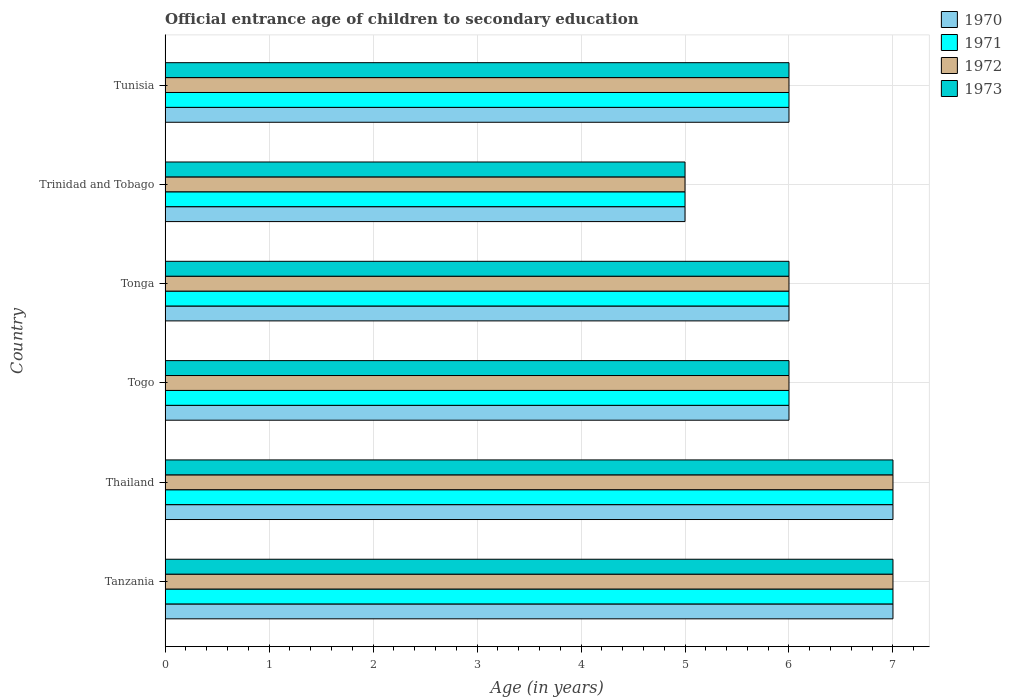How many different coloured bars are there?
Give a very brief answer. 4. How many groups of bars are there?
Your response must be concise. 6. Are the number of bars on each tick of the Y-axis equal?
Offer a very short reply. Yes. What is the label of the 4th group of bars from the top?
Provide a short and direct response. Togo. In how many cases, is the number of bars for a given country not equal to the number of legend labels?
Your response must be concise. 0. Across all countries, what is the minimum secondary school starting age of children in 1973?
Your answer should be very brief. 5. In which country was the secondary school starting age of children in 1972 maximum?
Provide a succinct answer. Tanzania. In which country was the secondary school starting age of children in 1970 minimum?
Provide a succinct answer. Trinidad and Tobago. What is the total secondary school starting age of children in 1972 in the graph?
Provide a succinct answer. 37. What is the difference between the secondary school starting age of children in 1973 in Togo and the secondary school starting age of children in 1970 in Thailand?
Provide a short and direct response. -1. What is the average secondary school starting age of children in 1973 per country?
Your response must be concise. 6.17. What is the difference between the secondary school starting age of children in 1973 and secondary school starting age of children in 1970 in Togo?
Your answer should be compact. 0. What is the ratio of the secondary school starting age of children in 1971 in Trinidad and Tobago to that in Tunisia?
Provide a short and direct response. 0.83. Is the difference between the secondary school starting age of children in 1973 in Trinidad and Tobago and Tunisia greater than the difference between the secondary school starting age of children in 1970 in Trinidad and Tobago and Tunisia?
Provide a short and direct response. No. What is the difference between the highest and the lowest secondary school starting age of children in 1970?
Keep it short and to the point. 2. In how many countries, is the secondary school starting age of children in 1973 greater than the average secondary school starting age of children in 1973 taken over all countries?
Make the answer very short. 2. Is the sum of the secondary school starting age of children in 1970 in Trinidad and Tobago and Tunisia greater than the maximum secondary school starting age of children in 1973 across all countries?
Offer a very short reply. Yes. What does the 1st bar from the top in Trinidad and Tobago represents?
Your answer should be very brief. 1973. Is it the case that in every country, the sum of the secondary school starting age of children in 1970 and secondary school starting age of children in 1972 is greater than the secondary school starting age of children in 1973?
Make the answer very short. Yes. How many bars are there?
Make the answer very short. 24. What is the difference between two consecutive major ticks on the X-axis?
Offer a very short reply. 1. Are the values on the major ticks of X-axis written in scientific E-notation?
Offer a terse response. No. Does the graph contain any zero values?
Give a very brief answer. No. How are the legend labels stacked?
Your response must be concise. Vertical. What is the title of the graph?
Offer a very short reply. Official entrance age of children to secondary education. Does "1977" appear as one of the legend labels in the graph?
Offer a terse response. No. What is the label or title of the X-axis?
Your response must be concise. Age (in years). What is the label or title of the Y-axis?
Ensure brevity in your answer.  Country. What is the Age (in years) of 1970 in Tanzania?
Your response must be concise. 7. What is the Age (in years) in 1972 in Thailand?
Offer a terse response. 7. What is the Age (in years) in 1971 in Togo?
Offer a terse response. 6. What is the Age (in years) of 1972 in Togo?
Ensure brevity in your answer.  6. What is the Age (in years) of 1973 in Togo?
Provide a short and direct response. 6. What is the Age (in years) in 1970 in Tonga?
Your answer should be compact. 6. What is the Age (in years) of 1972 in Tonga?
Provide a succinct answer. 6. What is the Age (in years) in 1973 in Tonga?
Make the answer very short. 6. What is the Age (in years) in 1971 in Trinidad and Tobago?
Your response must be concise. 5. What is the Age (in years) of 1972 in Trinidad and Tobago?
Provide a short and direct response. 5. What is the Age (in years) in 1973 in Trinidad and Tobago?
Keep it short and to the point. 5. What is the Age (in years) in 1973 in Tunisia?
Your answer should be very brief. 6. Across all countries, what is the maximum Age (in years) in 1970?
Your answer should be compact. 7. Across all countries, what is the maximum Age (in years) in 1971?
Your answer should be very brief. 7. Across all countries, what is the maximum Age (in years) of 1973?
Offer a very short reply. 7. Across all countries, what is the minimum Age (in years) of 1970?
Provide a succinct answer. 5. Across all countries, what is the minimum Age (in years) of 1971?
Make the answer very short. 5. What is the total Age (in years) in 1970 in the graph?
Keep it short and to the point. 37. What is the total Age (in years) in 1973 in the graph?
Ensure brevity in your answer.  37. What is the difference between the Age (in years) of 1971 in Tanzania and that in Thailand?
Provide a short and direct response. 0. What is the difference between the Age (in years) in 1972 in Tanzania and that in Thailand?
Provide a succinct answer. 0. What is the difference between the Age (in years) of 1973 in Tanzania and that in Thailand?
Provide a succinct answer. 0. What is the difference between the Age (in years) in 1970 in Tanzania and that in Togo?
Keep it short and to the point. 1. What is the difference between the Age (in years) of 1971 in Tanzania and that in Togo?
Give a very brief answer. 1. What is the difference between the Age (in years) of 1973 in Tanzania and that in Togo?
Give a very brief answer. 1. What is the difference between the Age (in years) in 1970 in Tanzania and that in Tonga?
Give a very brief answer. 1. What is the difference between the Age (in years) in 1970 in Tanzania and that in Trinidad and Tobago?
Make the answer very short. 2. What is the difference between the Age (in years) of 1972 in Tanzania and that in Trinidad and Tobago?
Give a very brief answer. 2. What is the difference between the Age (in years) of 1970 in Tanzania and that in Tunisia?
Provide a succinct answer. 1. What is the difference between the Age (in years) in 1971 in Tanzania and that in Tunisia?
Your answer should be compact. 1. What is the difference between the Age (in years) in 1973 in Tanzania and that in Tunisia?
Make the answer very short. 1. What is the difference between the Age (in years) of 1970 in Thailand and that in Togo?
Offer a terse response. 1. What is the difference between the Age (in years) in 1972 in Thailand and that in Togo?
Your response must be concise. 1. What is the difference between the Age (in years) of 1973 in Thailand and that in Togo?
Offer a very short reply. 1. What is the difference between the Age (in years) in 1972 in Thailand and that in Tonga?
Offer a terse response. 1. What is the difference between the Age (in years) in 1973 in Thailand and that in Tonga?
Make the answer very short. 1. What is the difference between the Age (in years) in 1971 in Thailand and that in Trinidad and Tobago?
Your answer should be compact. 2. What is the difference between the Age (in years) in 1972 in Thailand and that in Trinidad and Tobago?
Your response must be concise. 2. What is the difference between the Age (in years) of 1970 in Thailand and that in Tunisia?
Your answer should be compact. 1. What is the difference between the Age (in years) of 1971 in Thailand and that in Tunisia?
Keep it short and to the point. 1. What is the difference between the Age (in years) in 1973 in Thailand and that in Tunisia?
Ensure brevity in your answer.  1. What is the difference between the Age (in years) in 1970 in Togo and that in Tonga?
Ensure brevity in your answer.  0. What is the difference between the Age (in years) of 1972 in Togo and that in Tonga?
Provide a succinct answer. 0. What is the difference between the Age (in years) in 1973 in Togo and that in Tonga?
Your response must be concise. 0. What is the difference between the Age (in years) of 1970 in Togo and that in Trinidad and Tobago?
Your response must be concise. 1. What is the difference between the Age (in years) in 1973 in Togo and that in Trinidad and Tobago?
Your answer should be very brief. 1. What is the difference between the Age (in years) in 1972 in Togo and that in Tunisia?
Make the answer very short. 0. What is the difference between the Age (in years) in 1973 in Togo and that in Tunisia?
Provide a succinct answer. 0. What is the difference between the Age (in years) of 1970 in Tonga and that in Trinidad and Tobago?
Keep it short and to the point. 1. What is the difference between the Age (in years) in 1971 in Tonga and that in Trinidad and Tobago?
Your answer should be compact. 1. What is the difference between the Age (in years) of 1971 in Tonga and that in Tunisia?
Make the answer very short. 0. What is the difference between the Age (in years) in 1970 in Trinidad and Tobago and that in Tunisia?
Make the answer very short. -1. What is the difference between the Age (in years) of 1971 in Trinidad and Tobago and that in Tunisia?
Offer a very short reply. -1. What is the difference between the Age (in years) in 1972 in Trinidad and Tobago and that in Tunisia?
Offer a terse response. -1. What is the difference between the Age (in years) of 1970 in Tanzania and the Age (in years) of 1971 in Thailand?
Give a very brief answer. 0. What is the difference between the Age (in years) of 1970 in Tanzania and the Age (in years) of 1972 in Thailand?
Ensure brevity in your answer.  0. What is the difference between the Age (in years) in 1971 in Tanzania and the Age (in years) in 1973 in Thailand?
Your response must be concise. 0. What is the difference between the Age (in years) in 1970 in Tanzania and the Age (in years) in 1971 in Togo?
Your answer should be very brief. 1. What is the difference between the Age (in years) in 1970 in Tanzania and the Age (in years) in 1972 in Togo?
Your response must be concise. 1. What is the difference between the Age (in years) of 1972 in Tanzania and the Age (in years) of 1973 in Togo?
Keep it short and to the point. 1. What is the difference between the Age (in years) of 1970 in Tanzania and the Age (in years) of 1972 in Tonga?
Your answer should be compact. 1. What is the difference between the Age (in years) in 1971 in Tanzania and the Age (in years) in 1973 in Tonga?
Provide a short and direct response. 1. What is the difference between the Age (in years) in 1971 in Tanzania and the Age (in years) in 1973 in Trinidad and Tobago?
Your answer should be compact. 2. What is the difference between the Age (in years) of 1972 in Tanzania and the Age (in years) of 1973 in Trinidad and Tobago?
Your response must be concise. 2. What is the difference between the Age (in years) in 1971 in Tanzania and the Age (in years) in 1972 in Tunisia?
Keep it short and to the point. 1. What is the difference between the Age (in years) of 1970 in Thailand and the Age (in years) of 1972 in Togo?
Provide a succinct answer. 1. What is the difference between the Age (in years) in 1971 in Thailand and the Age (in years) in 1972 in Togo?
Your answer should be very brief. 1. What is the difference between the Age (in years) in 1970 in Thailand and the Age (in years) in 1971 in Tonga?
Provide a short and direct response. 1. What is the difference between the Age (in years) of 1970 in Thailand and the Age (in years) of 1972 in Tonga?
Offer a terse response. 1. What is the difference between the Age (in years) in 1970 in Thailand and the Age (in years) in 1973 in Tonga?
Provide a short and direct response. 1. What is the difference between the Age (in years) of 1972 in Thailand and the Age (in years) of 1973 in Tonga?
Make the answer very short. 1. What is the difference between the Age (in years) in 1970 in Thailand and the Age (in years) in 1972 in Tunisia?
Give a very brief answer. 1. What is the difference between the Age (in years) in 1970 in Thailand and the Age (in years) in 1973 in Tunisia?
Your answer should be very brief. 1. What is the difference between the Age (in years) of 1971 in Thailand and the Age (in years) of 1972 in Tunisia?
Make the answer very short. 1. What is the difference between the Age (in years) in 1972 in Thailand and the Age (in years) in 1973 in Tunisia?
Provide a succinct answer. 1. What is the difference between the Age (in years) in 1970 in Togo and the Age (in years) in 1971 in Tonga?
Offer a very short reply. 0. What is the difference between the Age (in years) of 1970 in Togo and the Age (in years) of 1972 in Tonga?
Offer a very short reply. 0. What is the difference between the Age (in years) of 1971 in Togo and the Age (in years) of 1972 in Tonga?
Make the answer very short. 0. What is the difference between the Age (in years) of 1972 in Togo and the Age (in years) of 1973 in Tonga?
Give a very brief answer. 0. What is the difference between the Age (in years) in 1970 in Togo and the Age (in years) in 1972 in Trinidad and Tobago?
Your answer should be very brief. 1. What is the difference between the Age (in years) in 1970 in Togo and the Age (in years) in 1973 in Trinidad and Tobago?
Provide a succinct answer. 1. What is the difference between the Age (in years) of 1971 in Togo and the Age (in years) of 1973 in Trinidad and Tobago?
Your answer should be compact. 1. What is the difference between the Age (in years) of 1972 in Togo and the Age (in years) of 1973 in Trinidad and Tobago?
Provide a short and direct response. 1. What is the difference between the Age (in years) in 1970 in Togo and the Age (in years) in 1972 in Tunisia?
Offer a very short reply. 0. What is the difference between the Age (in years) in 1970 in Togo and the Age (in years) in 1973 in Tunisia?
Ensure brevity in your answer.  0. What is the difference between the Age (in years) of 1971 in Togo and the Age (in years) of 1972 in Tunisia?
Provide a short and direct response. 0. What is the difference between the Age (in years) of 1971 in Togo and the Age (in years) of 1973 in Tunisia?
Offer a very short reply. 0. What is the difference between the Age (in years) of 1970 in Tonga and the Age (in years) of 1972 in Trinidad and Tobago?
Provide a succinct answer. 1. What is the difference between the Age (in years) in 1971 in Tonga and the Age (in years) in 1972 in Trinidad and Tobago?
Your response must be concise. 1. What is the difference between the Age (in years) in 1971 in Tonga and the Age (in years) in 1973 in Trinidad and Tobago?
Your answer should be compact. 1. What is the difference between the Age (in years) of 1970 in Tonga and the Age (in years) of 1971 in Tunisia?
Ensure brevity in your answer.  0. What is the difference between the Age (in years) in 1970 in Tonga and the Age (in years) in 1972 in Tunisia?
Offer a very short reply. 0. What is the difference between the Age (in years) in 1970 in Tonga and the Age (in years) in 1973 in Tunisia?
Make the answer very short. 0. What is the difference between the Age (in years) in 1971 in Trinidad and Tobago and the Age (in years) in 1972 in Tunisia?
Offer a very short reply. -1. What is the difference between the Age (in years) in 1972 in Trinidad and Tobago and the Age (in years) in 1973 in Tunisia?
Your answer should be compact. -1. What is the average Age (in years) of 1970 per country?
Your answer should be very brief. 6.17. What is the average Age (in years) in 1971 per country?
Keep it short and to the point. 6.17. What is the average Age (in years) in 1972 per country?
Keep it short and to the point. 6.17. What is the average Age (in years) of 1973 per country?
Give a very brief answer. 6.17. What is the difference between the Age (in years) in 1970 and Age (in years) in 1972 in Tanzania?
Offer a terse response. 0. What is the difference between the Age (in years) in 1971 and Age (in years) in 1973 in Tanzania?
Make the answer very short. 0. What is the difference between the Age (in years) in 1970 and Age (in years) in 1971 in Thailand?
Offer a terse response. 0. What is the difference between the Age (in years) of 1970 and Age (in years) of 1972 in Thailand?
Your answer should be very brief. 0. What is the difference between the Age (in years) of 1970 and Age (in years) of 1973 in Thailand?
Ensure brevity in your answer.  0. What is the difference between the Age (in years) in 1971 and Age (in years) in 1972 in Thailand?
Provide a succinct answer. 0. What is the difference between the Age (in years) in 1972 and Age (in years) in 1973 in Thailand?
Keep it short and to the point. 0. What is the difference between the Age (in years) of 1971 and Age (in years) of 1972 in Togo?
Offer a terse response. 0. What is the difference between the Age (in years) in 1972 and Age (in years) in 1973 in Togo?
Provide a succinct answer. 0. What is the difference between the Age (in years) in 1970 and Age (in years) in 1972 in Tonga?
Your response must be concise. 0. What is the difference between the Age (in years) of 1971 and Age (in years) of 1972 in Tonga?
Your response must be concise. 0. What is the difference between the Age (in years) of 1971 and Age (in years) of 1973 in Tonga?
Your answer should be very brief. 0. What is the difference between the Age (in years) of 1970 and Age (in years) of 1972 in Trinidad and Tobago?
Keep it short and to the point. 0. What is the difference between the Age (in years) of 1971 and Age (in years) of 1972 in Trinidad and Tobago?
Your response must be concise. 0. What is the difference between the Age (in years) in 1972 and Age (in years) in 1973 in Trinidad and Tobago?
Provide a succinct answer. 0. What is the difference between the Age (in years) of 1970 and Age (in years) of 1971 in Tunisia?
Your answer should be very brief. 0. What is the difference between the Age (in years) of 1971 and Age (in years) of 1972 in Tunisia?
Offer a very short reply. 0. What is the difference between the Age (in years) of 1971 and Age (in years) of 1973 in Tunisia?
Your answer should be compact. 0. What is the ratio of the Age (in years) of 1971 in Tanzania to that in Thailand?
Offer a terse response. 1. What is the ratio of the Age (in years) in 1972 in Tanzania to that in Thailand?
Offer a terse response. 1. What is the ratio of the Age (in years) in 1970 in Tanzania to that in Togo?
Ensure brevity in your answer.  1.17. What is the ratio of the Age (in years) in 1971 in Tanzania to that in Togo?
Make the answer very short. 1.17. What is the ratio of the Age (in years) of 1973 in Tanzania to that in Togo?
Make the answer very short. 1.17. What is the ratio of the Age (in years) of 1972 in Tanzania to that in Tonga?
Give a very brief answer. 1.17. What is the ratio of the Age (in years) in 1971 in Tanzania to that in Trinidad and Tobago?
Your response must be concise. 1.4. What is the ratio of the Age (in years) in 1973 in Tanzania to that in Trinidad and Tobago?
Give a very brief answer. 1.4. What is the ratio of the Age (in years) in 1970 in Tanzania to that in Tunisia?
Provide a succinct answer. 1.17. What is the ratio of the Age (in years) in 1971 in Tanzania to that in Tunisia?
Keep it short and to the point. 1.17. What is the ratio of the Age (in years) of 1973 in Tanzania to that in Tunisia?
Make the answer very short. 1.17. What is the ratio of the Age (in years) in 1973 in Thailand to that in Togo?
Offer a very short reply. 1.17. What is the ratio of the Age (in years) in 1972 in Thailand to that in Tonga?
Provide a short and direct response. 1.17. What is the ratio of the Age (in years) in 1973 in Thailand to that in Tonga?
Provide a short and direct response. 1.17. What is the ratio of the Age (in years) of 1972 in Thailand to that in Trinidad and Tobago?
Provide a short and direct response. 1.4. What is the ratio of the Age (in years) in 1972 in Thailand to that in Tunisia?
Make the answer very short. 1.17. What is the ratio of the Age (in years) of 1973 in Thailand to that in Tunisia?
Your answer should be compact. 1.17. What is the ratio of the Age (in years) in 1970 in Togo to that in Tonga?
Your answer should be very brief. 1. What is the ratio of the Age (in years) of 1972 in Togo to that in Tonga?
Offer a terse response. 1. What is the ratio of the Age (in years) in 1971 in Togo to that in Trinidad and Tobago?
Provide a succinct answer. 1.2. What is the ratio of the Age (in years) of 1973 in Togo to that in Trinidad and Tobago?
Your answer should be very brief. 1.2. What is the ratio of the Age (in years) of 1971 in Togo to that in Tunisia?
Make the answer very short. 1. What is the ratio of the Age (in years) in 1972 in Togo to that in Tunisia?
Keep it short and to the point. 1. What is the ratio of the Age (in years) in 1973 in Togo to that in Tunisia?
Your answer should be very brief. 1. What is the ratio of the Age (in years) in 1970 in Tonga to that in Trinidad and Tobago?
Provide a short and direct response. 1.2. What is the ratio of the Age (in years) in 1972 in Tonga to that in Tunisia?
Give a very brief answer. 1. What is the ratio of the Age (in years) of 1970 in Trinidad and Tobago to that in Tunisia?
Offer a very short reply. 0.83. What is the difference between the highest and the second highest Age (in years) of 1971?
Your response must be concise. 0. What is the difference between the highest and the second highest Age (in years) in 1972?
Make the answer very short. 0. What is the difference between the highest and the second highest Age (in years) of 1973?
Your response must be concise. 0. What is the difference between the highest and the lowest Age (in years) in 1971?
Make the answer very short. 2. What is the difference between the highest and the lowest Age (in years) of 1973?
Your answer should be very brief. 2. 